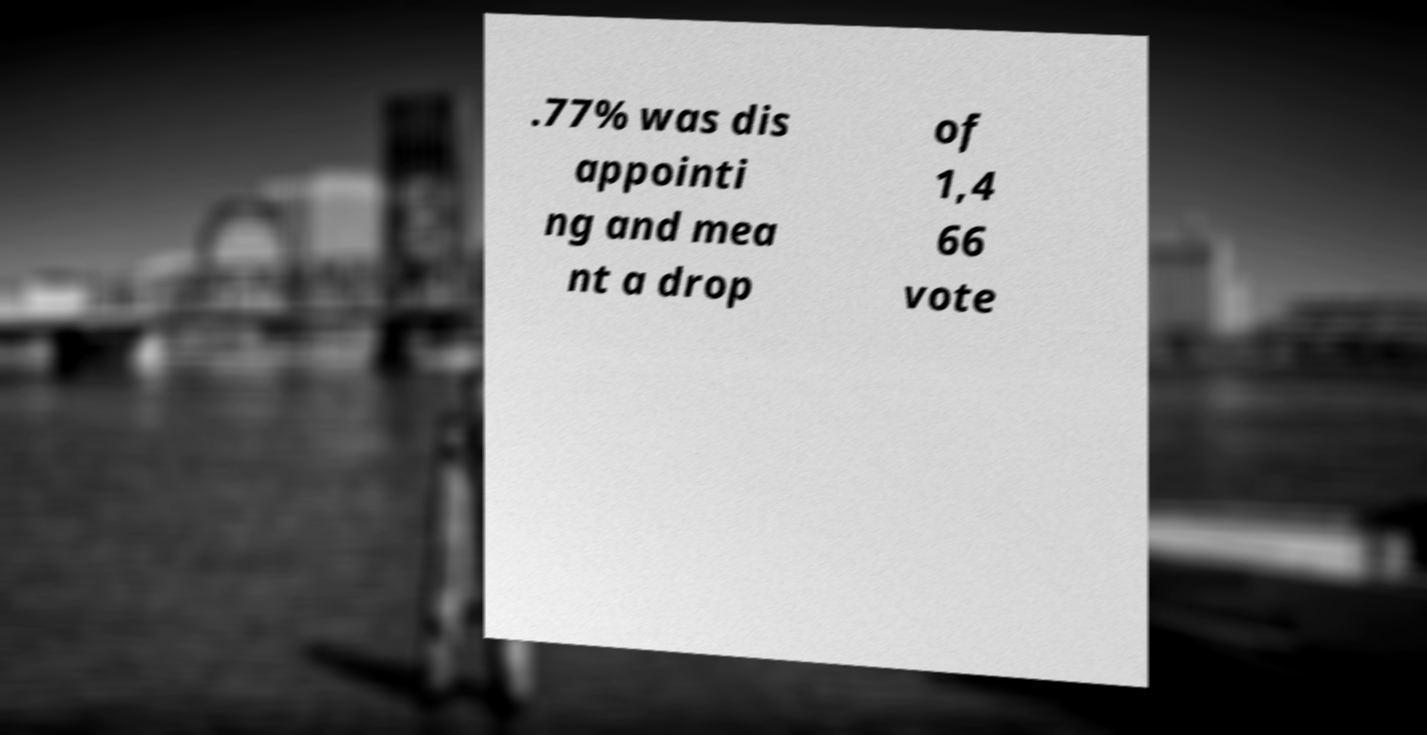What messages or text are displayed in this image? I need them in a readable, typed format. .77% was dis appointi ng and mea nt a drop of 1,4 66 vote 